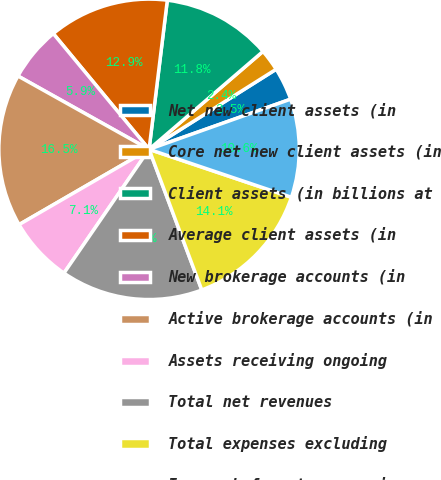Convert chart. <chart><loc_0><loc_0><loc_500><loc_500><pie_chart><fcel>Net new client assets (in<fcel>Core net new client assets (in<fcel>Client assets (in billions at<fcel>Average client assets (in<fcel>New brokerage accounts (in<fcel>Active brokerage accounts (in<fcel>Assets receiving ongoing<fcel>Total net revenues<fcel>Total expenses excluding<fcel>Income before taxes on income<nl><fcel>3.53%<fcel>2.35%<fcel>11.76%<fcel>12.94%<fcel>5.88%<fcel>16.47%<fcel>7.06%<fcel>15.29%<fcel>14.12%<fcel>10.59%<nl></chart> 